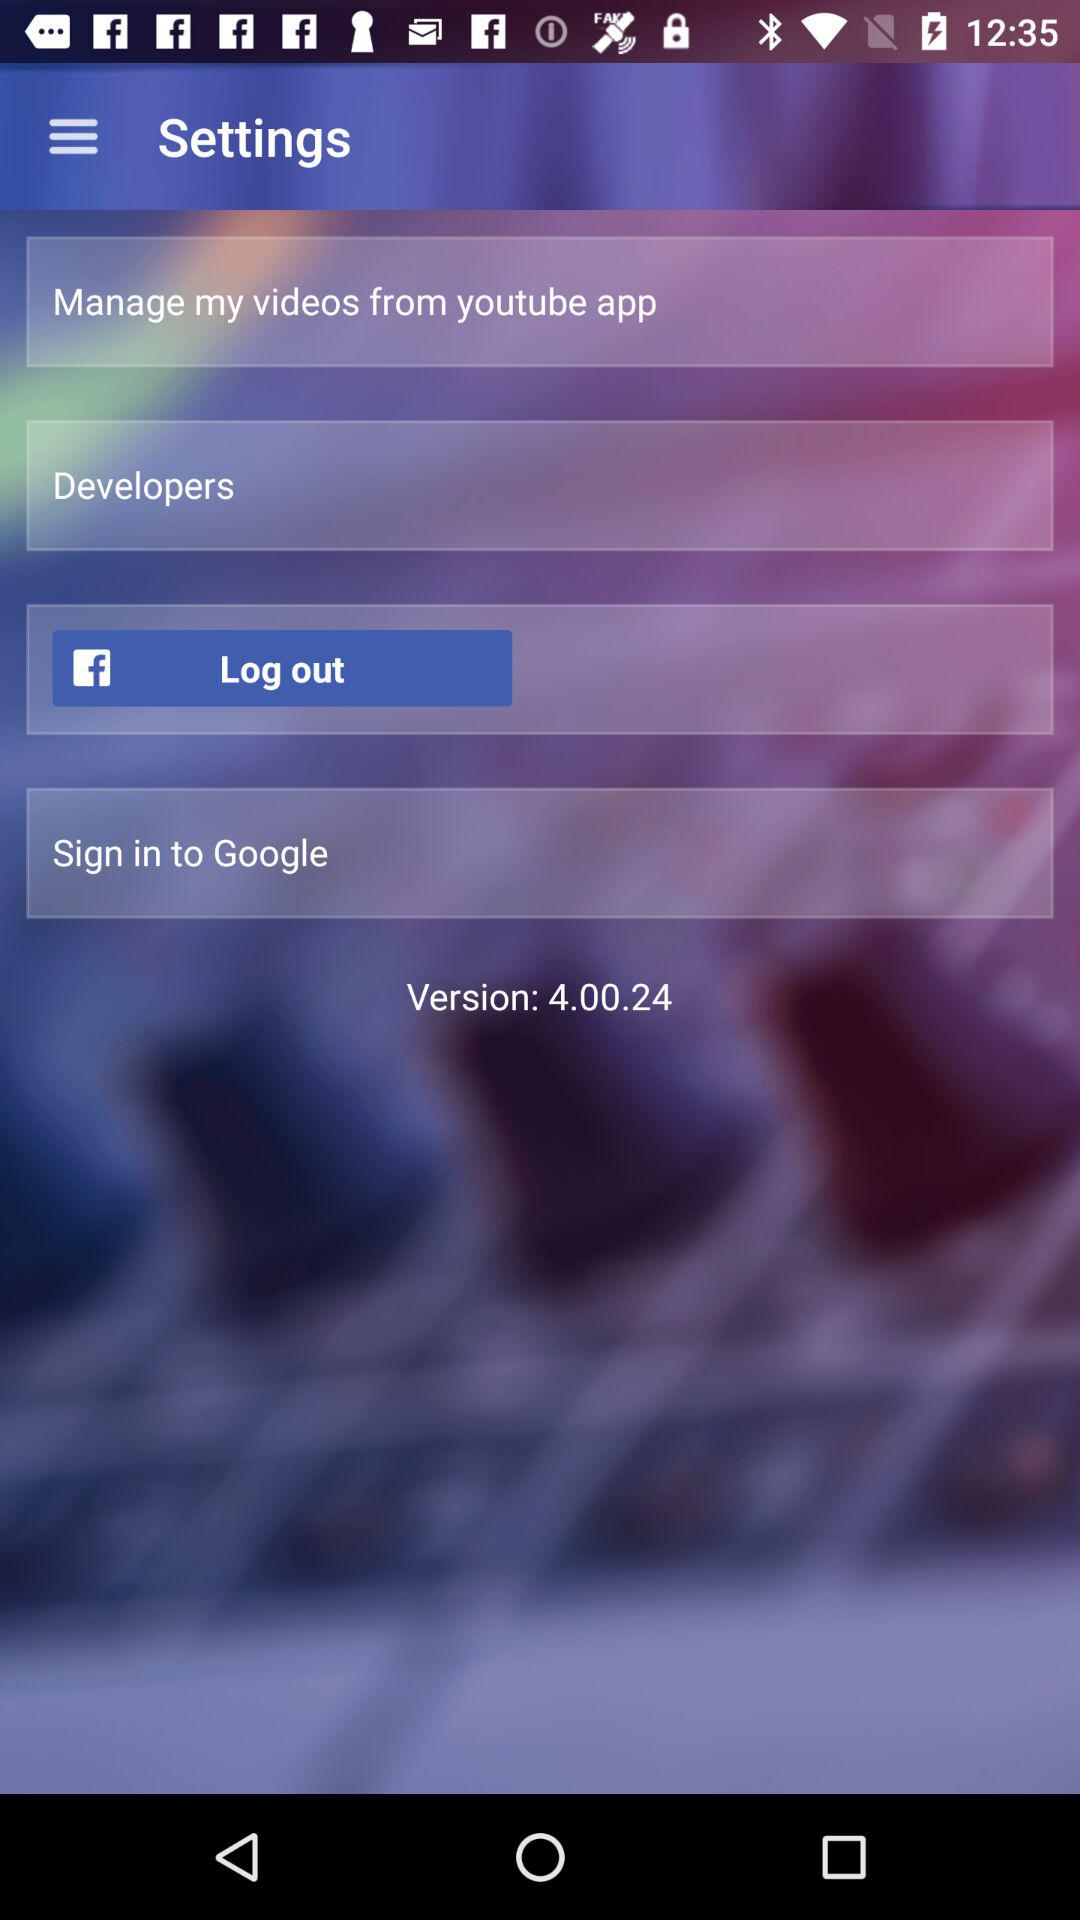What version of the application is this? The version of the application is 4.00.24. 